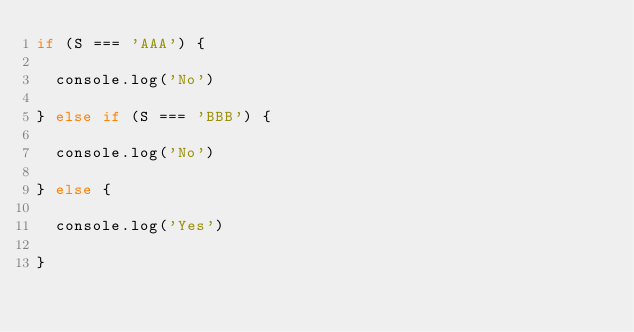Convert code to text. <code><loc_0><loc_0><loc_500><loc_500><_JavaScript_>if (S === 'AAA') {
  
  console.log('No')
  
} else if (S === 'BBB') {
          
  console.log('No')
  
} else {

  console.log('Yes')
  
}</code> 